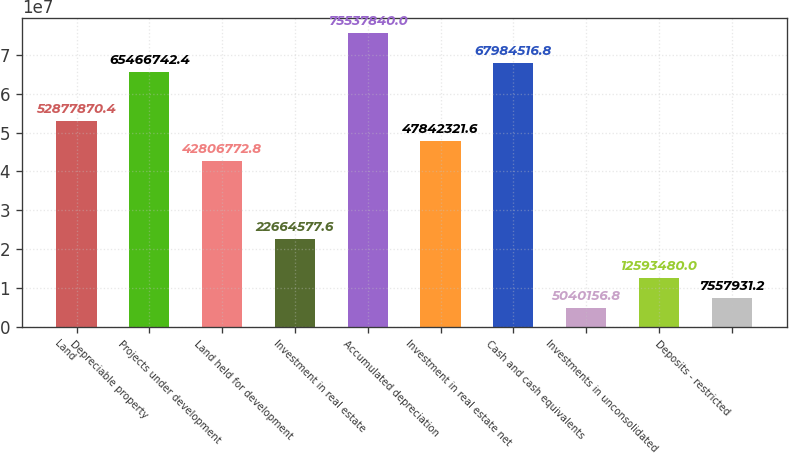Convert chart. <chart><loc_0><loc_0><loc_500><loc_500><bar_chart><fcel>Land<fcel>Depreciable property<fcel>Projects under development<fcel>Land held for development<fcel>Investment in real estate<fcel>Accumulated depreciation<fcel>Investment in real estate net<fcel>Cash and cash equivalents<fcel>Investments in unconsolidated<fcel>Deposits - restricted<nl><fcel>5.28779e+07<fcel>6.54667e+07<fcel>4.28068e+07<fcel>2.26646e+07<fcel>7.55378e+07<fcel>4.78423e+07<fcel>6.79845e+07<fcel>5.04016e+06<fcel>1.25935e+07<fcel>7.55793e+06<nl></chart> 